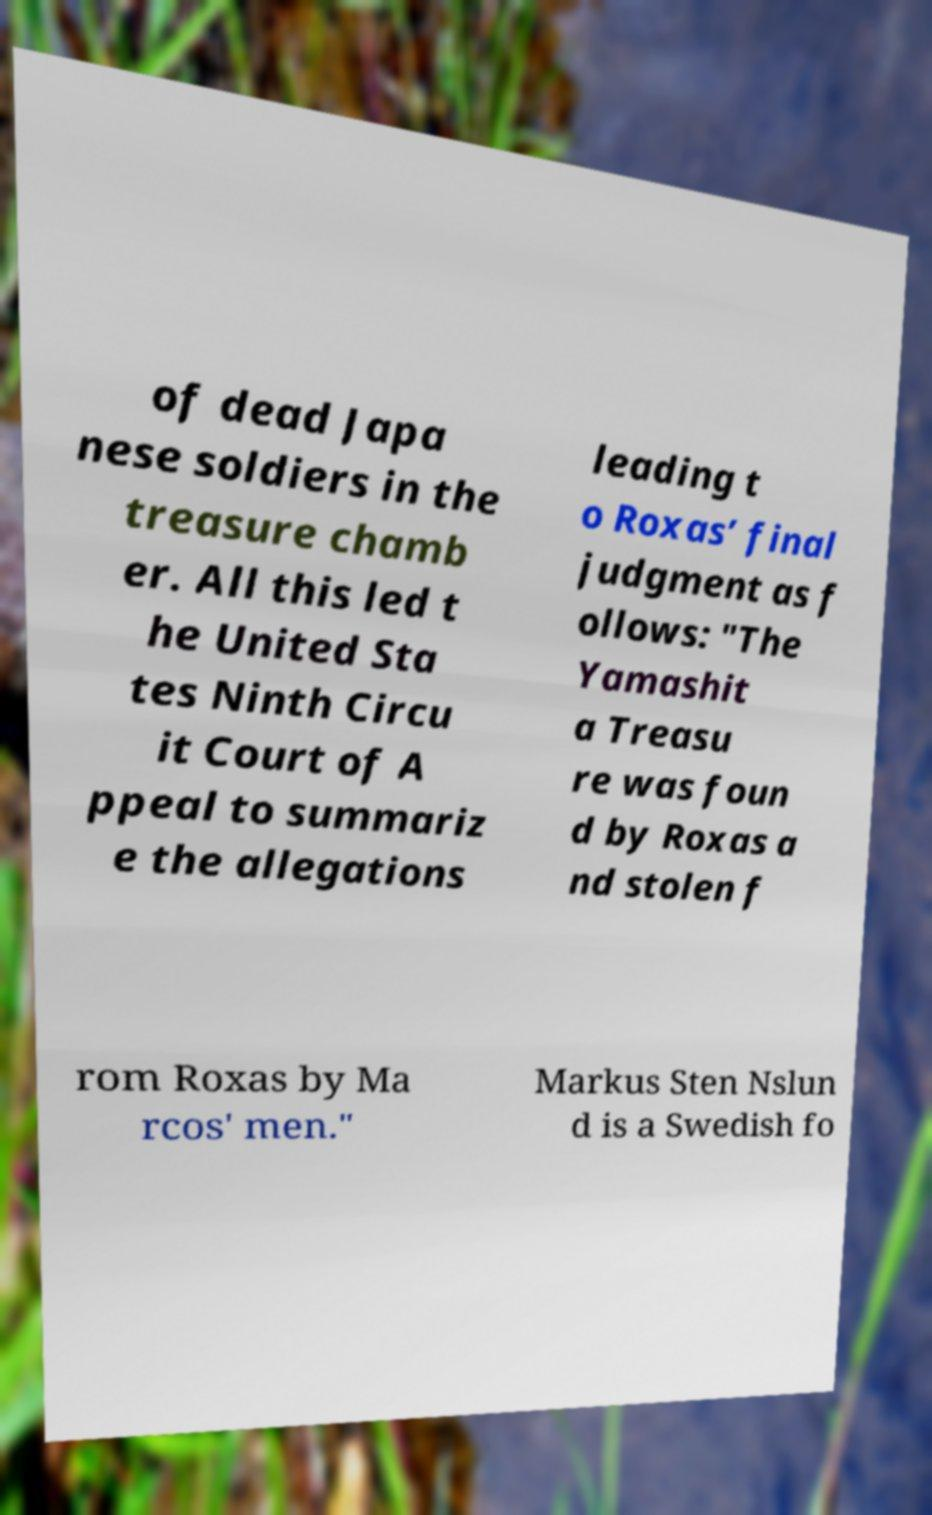Can you read and provide the text displayed in the image?This photo seems to have some interesting text. Can you extract and type it out for me? of dead Japa nese soldiers in the treasure chamb er. All this led t he United Sta tes Ninth Circu it Court of A ppeal to summariz e the allegations leading t o Roxas’ final judgment as f ollows: "The Yamashit a Treasu re was foun d by Roxas a nd stolen f rom Roxas by Ma rcos' men." Markus Sten Nslun d is a Swedish fo 